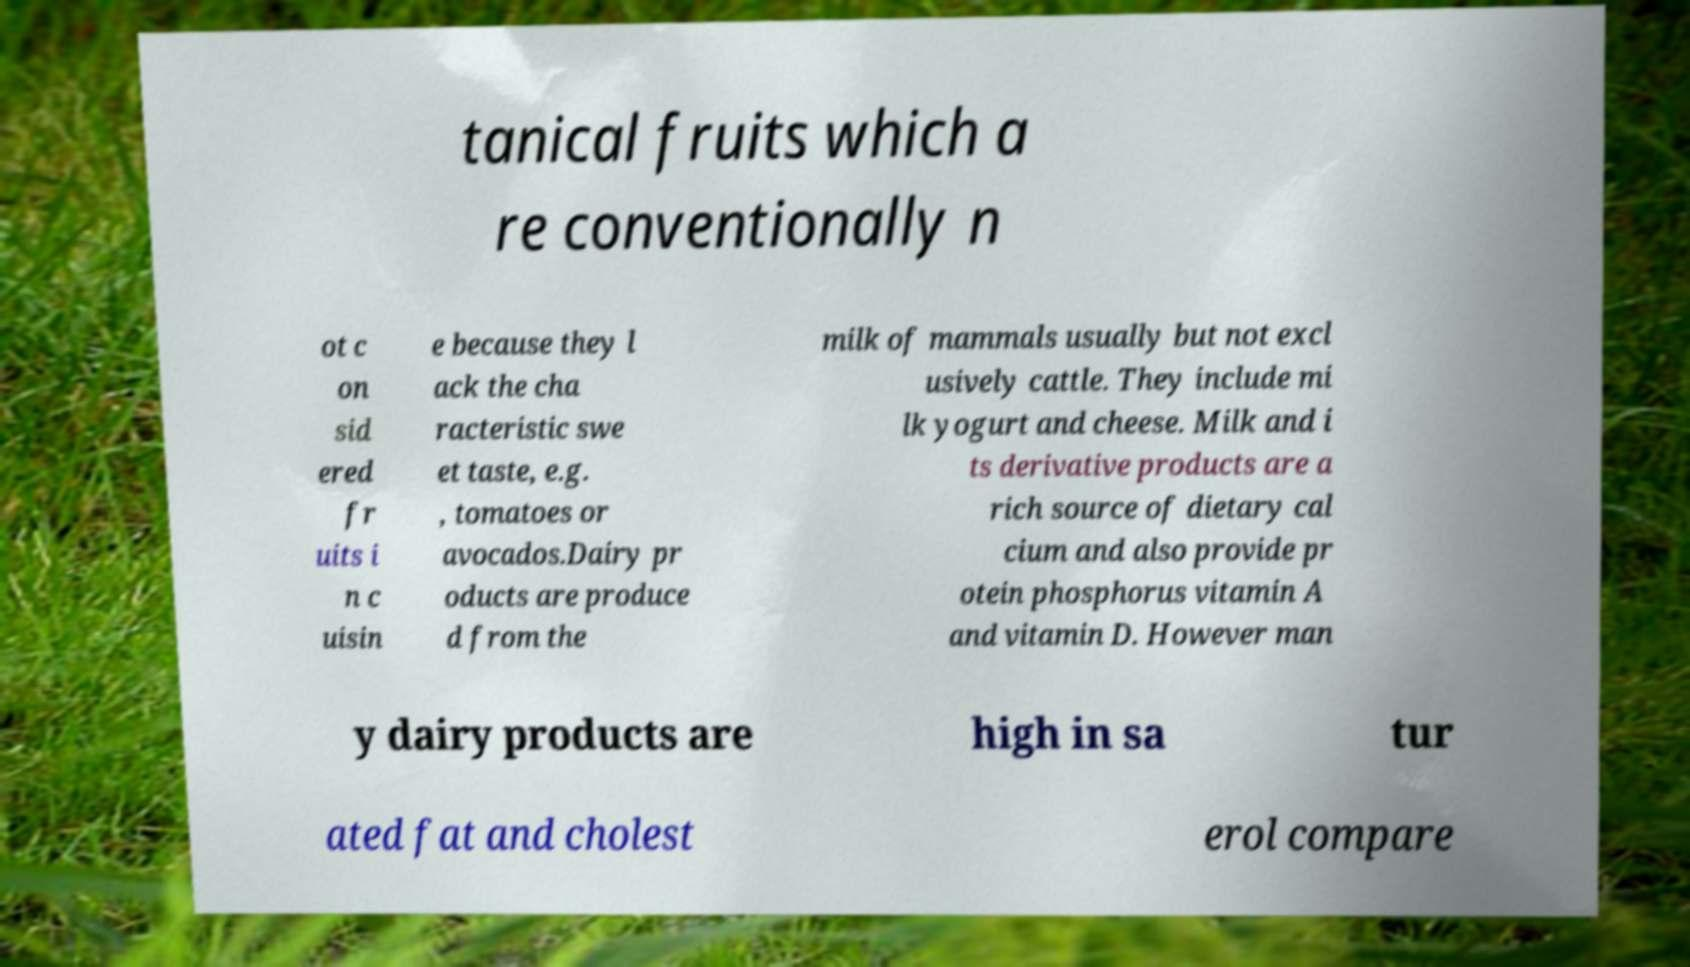Can you read and provide the text displayed in the image?This photo seems to have some interesting text. Can you extract and type it out for me? tanical fruits which a re conventionally n ot c on sid ered fr uits i n c uisin e because they l ack the cha racteristic swe et taste, e.g. , tomatoes or avocados.Dairy pr oducts are produce d from the milk of mammals usually but not excl usively cattle. They include mi lk yogurt and cheese. Milk and i ts derivative products are a rich source of dietary cal cium and also provide pr otein phosphorus vitamin A and vitamin D. However man y dairy products are high in sa tur ated fat and cholest erol compare 